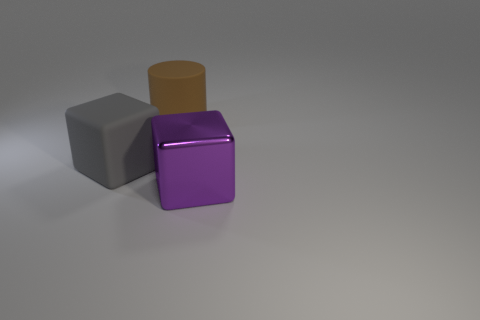Add 1 gray matte objects. How many objects exist? 4 Subtract all cylinders. How many objects are left? 2 Add 3 big shiny cubes. How many big shiny cubes exist? 4 Subtract 1 brown cylinders. How many objects are left? 2 Subtract all tiny purple shiny objects. Subtract all gray cubes. How many objects are left? 2 Add 2 metallic cubes. How many metallic cubes are left? 3 